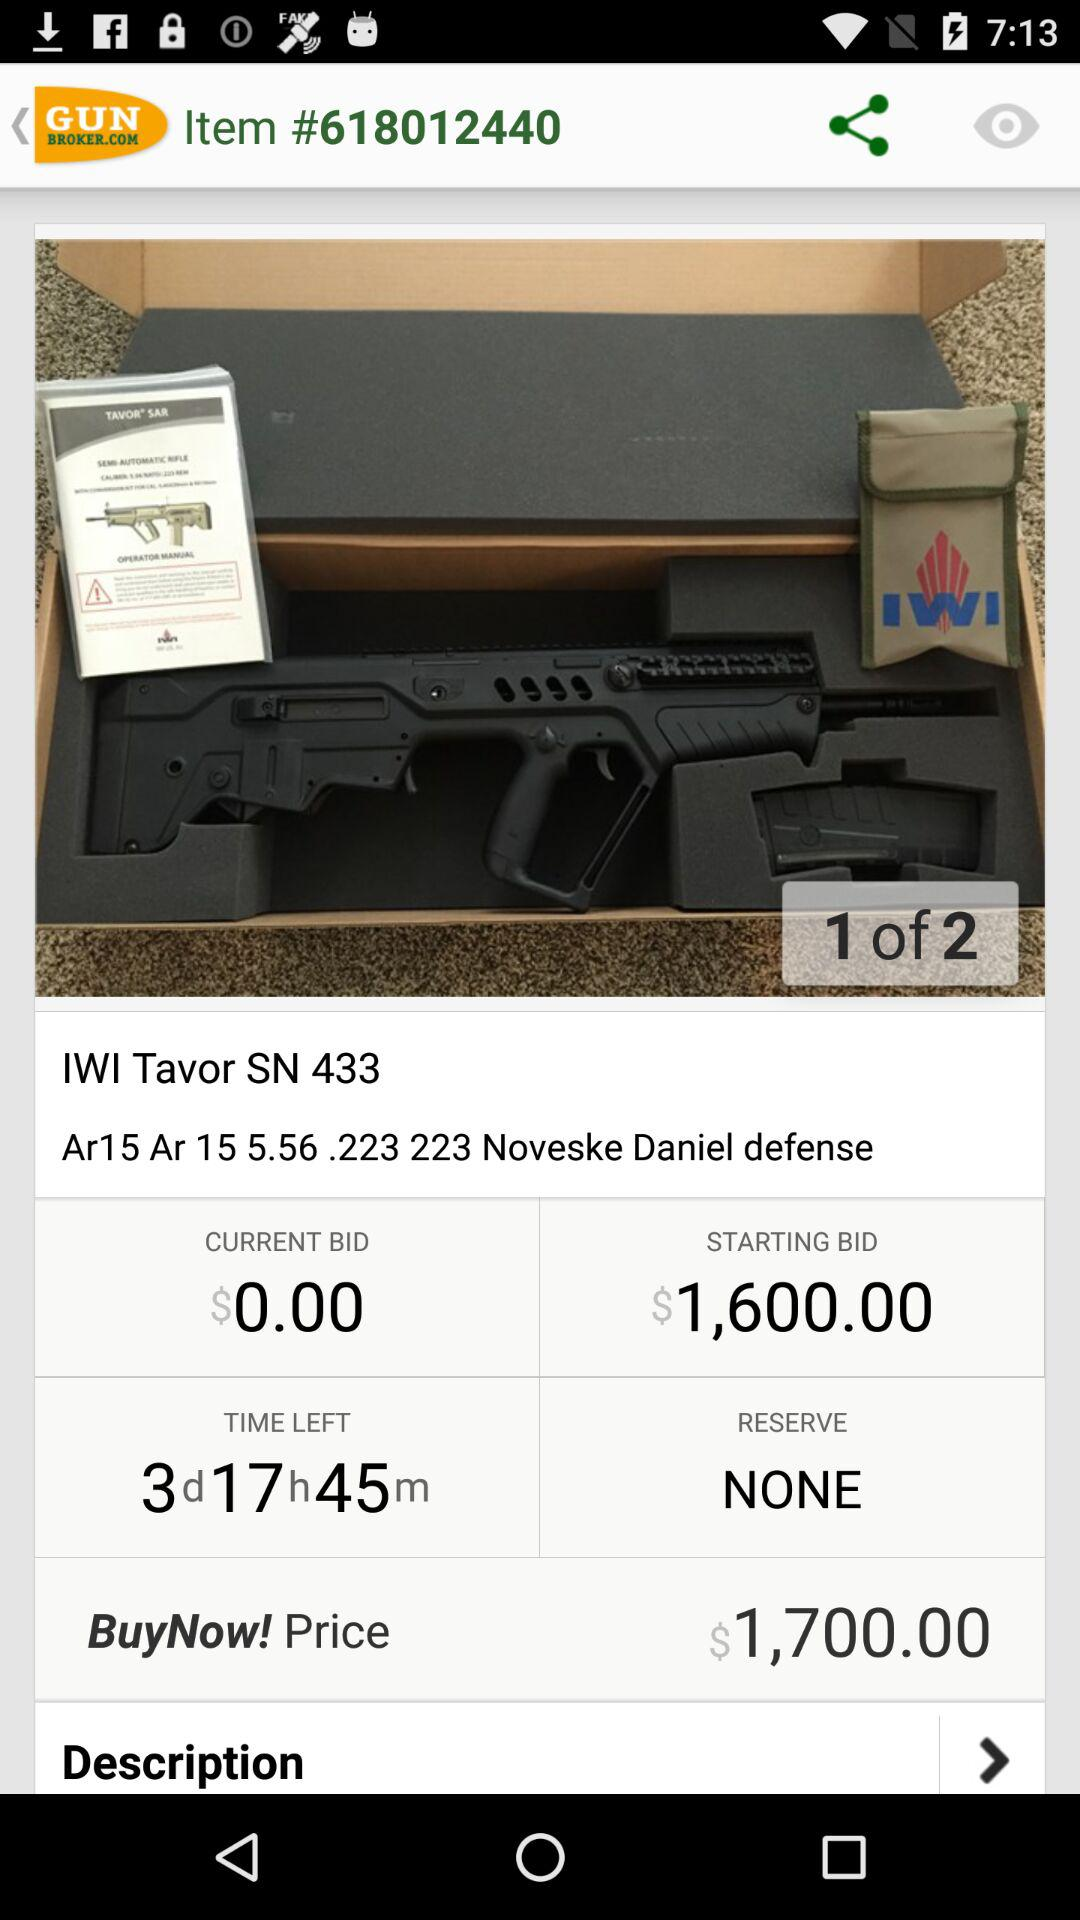On which page is the user out of total pages? The user is on the first page. 